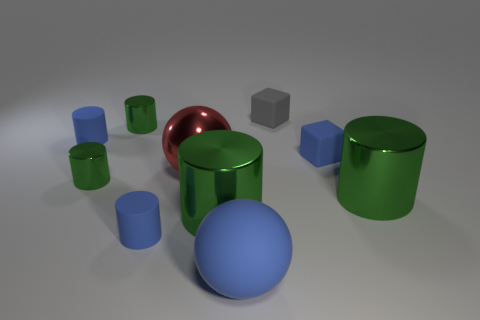Subtract all green cylinders. How many were subtracted if there are1green cylinders left? 3 Subtract all blue cubes. How many green cylinders are left? 4 Subtract 1 cylinders. How many cylinders are left? 5 Subtract all blue cylinders. How many cylinders are left? 4 Subtract all purple cylinders. Subtract all gray balls. How many cylinders are left? 6 Subtract all cylinders. How many objects are left? 4 Subtract 0 gray cylinders. How many objects are left? 10 Subtract all shiny cylinders. Subtract all matte blocks. How many objects are left? 4 Add 9 large blue balls. How many large blue balls are left? 10 Add 6 big yellow rubber balls. How many big yellow rubber balls exist? 6 